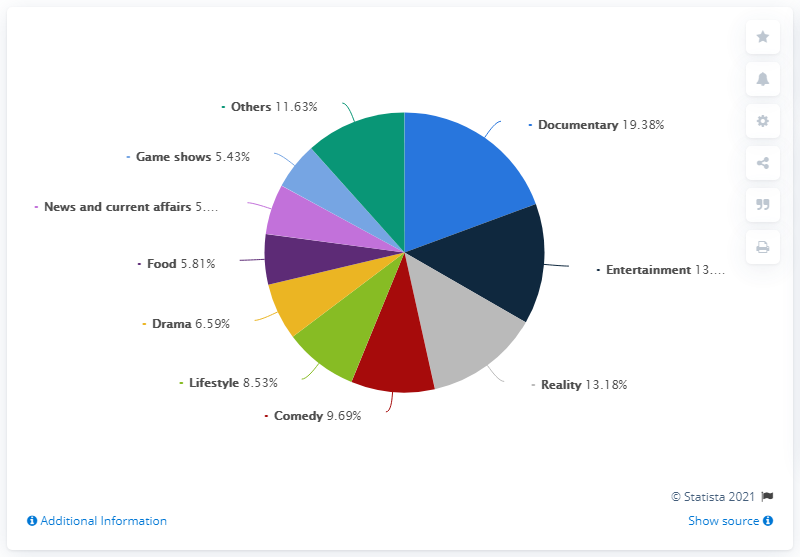How many genres have been considered? Based on the pie chart, there are 8 distinct genres shown, which are Documentary, Entertainment, Reality, Comedy, Lifestyle, Drama, Food, and Game shows. The 'Others' category might include additional genres not specified in the chart. 